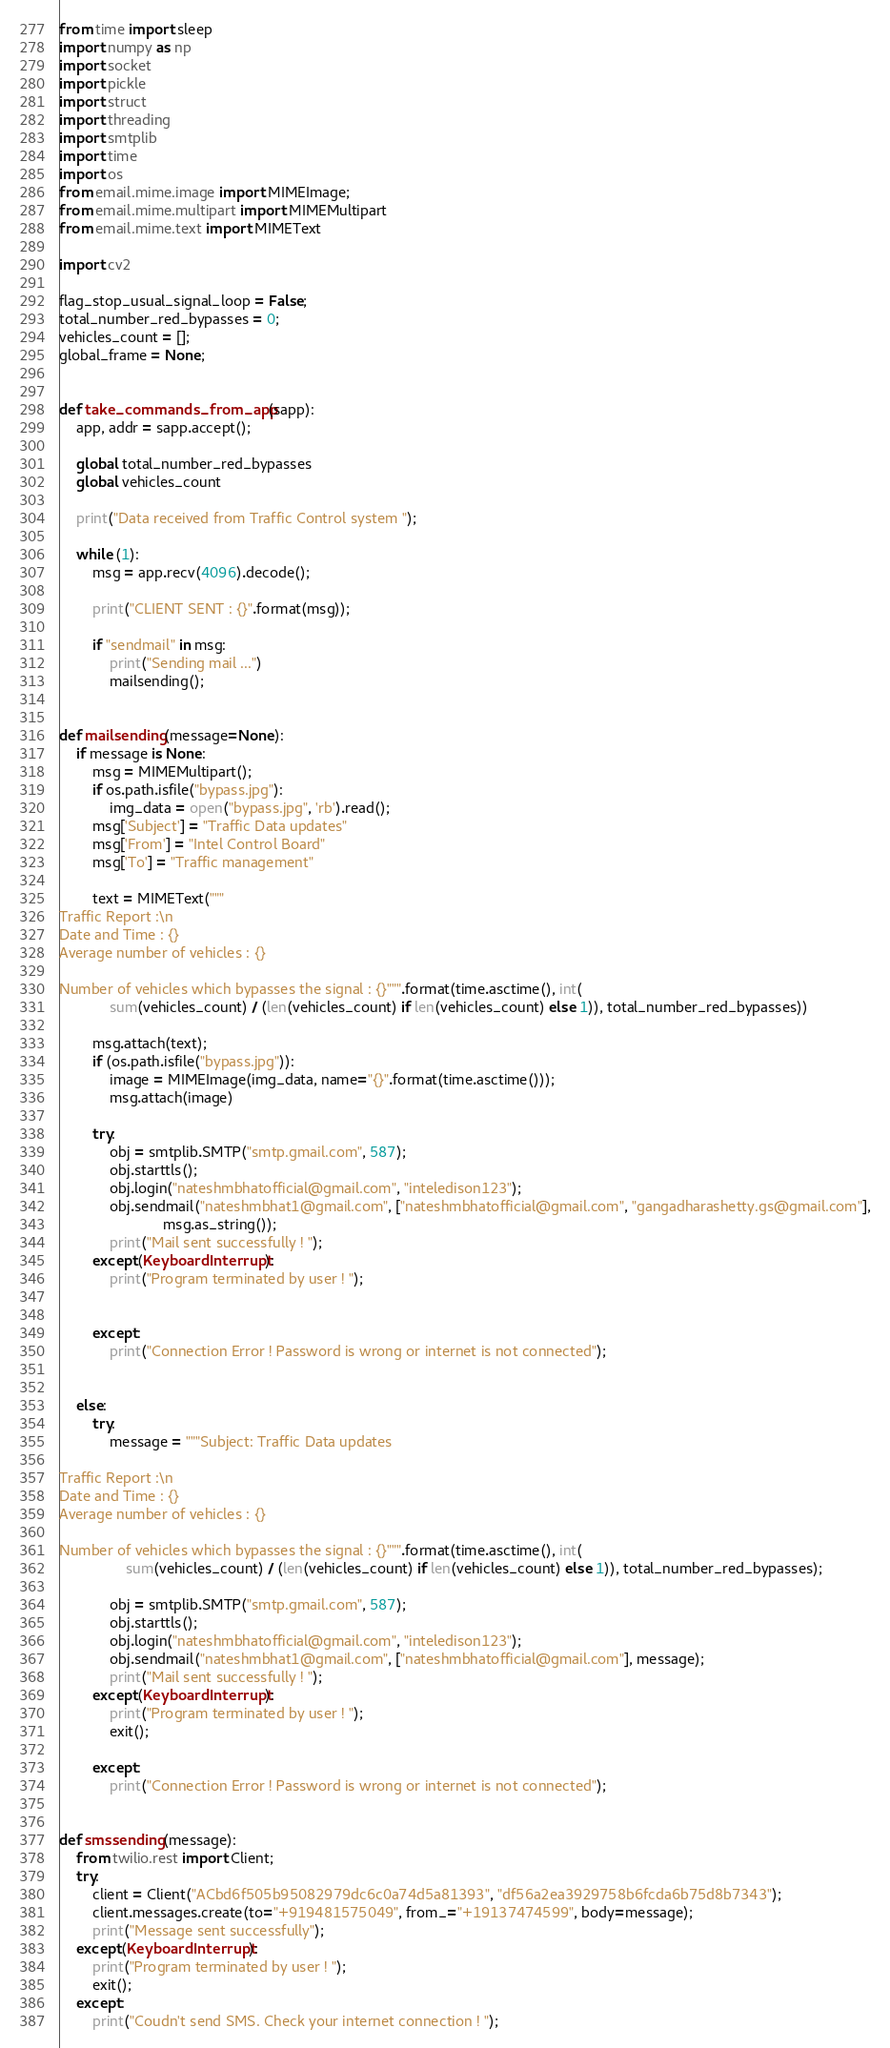<code> <loc_0><loc_0><loc_500><loc_500><_Python_>from time import sleep
import numpy as np
import socket
import pickle
import struct
import threading
import smtplib
import time
import os
from email.mime.image import MIMEImage;
from email.mime.multipart import MIMEMultipart
from email.mime.text import MIMEText

import cv2

flag_stop_usual_signal_loop = False;
total_number_red_bypasses = 0;
vehicles_count = [];
global_frame = None;


def take_commands_from_app(sapp):
    app, addr = sapp.accept();

    global total_number_red_bypasses
    global vehicles_count

    print("Data received from Traffic Control system ");

    while (1):
        msg = app.recv(4096).decode();

        print("CLIENT SENT : {}".format(msg));

        if "sendmail" in msg:
            print("Sending mail ...")
            mailsending();


def mailsending(message=None):
    if message is None:
        msg = MIMEMultipart();
        if os.path.isfile("bypass.jpg"):
            img_data = open("bypass.jpg", 'rb').read();
        msg['Subject'] = "Traffic Data updates"
        msg['From'] = "Intel Control Board"
        msg['To'] = "Traffic management"

        text = MIMEText("""
Traffic Report :\n
Date and Time : {}
Average number of vehicles : {}

Number of vehicles which bypasses the signal : {}""".format(time.asctime(), int(
            sum(vehicles_count) / (len(vehicles_count) if len(vehicles_count) else 1)), total_number_red_bypasses))

        msg.attach(text);
        if (os.path.isfile("bypass.jpg")):
            image = MIMEImage(img_data, name="{}".format(time.asctime()));
            msg.attach(image)

        try:
            obj = smtplib.SMTP("smtp.gmail.com", 587);
            obj.starttls();
            obj.login("nateshmbhatofficial@gmail.com", "inteledison123");
            obj.sendmail("nateshmbhat1@gmail.com", ["nateshmbhatofficial@gmail.com", "gangadharashetty.gs@gmail.com"],
                         msg.as_string());
            print("Mail sent successfully ! ");
        except(KeyboardInterrupt):
            print("Program terminated by user ! ");


        except:
            print("Connection Error ! Password is wrong or internet is not connected");


    else:
        try:
            message = """Subject: Traffic Data updates

Traffic Report :\n
Date and Time : {}
Average number of vehicles : {}

Number of vehicles which bypasses the signal : {}""".format(time.asctime(), int(
                sum(vehicles_count) / (len(vehicles_count) if len(vehicles_count) else 1)), total_number_red_bypasses);

            obj = smtplib.SMTP("smtp.gmail.com", 587);
            obj.starttls();
            obj.login("nateshmbhatofficial@gmail.com", "inteledison123");
            obj.sendmail("nateshmbhat1@gmail.com", ["nateshmbhatofficial@gmail.com"], message);
            print("Mail sent successfully ! ");
        except(KeyboardInterrupt):
            print("Program terminated by user ! ");
            exit();

        except:
            print("Connection Error ! Password is wrong or internet is not connected");


def smssending(message):
    from twilio.rest import Client;
    try:
        client = Client("ACbd6f505b95082979dc6c0a74d5a81393", "df56a2ea3929758b6fcda6b75d8b7343");
        client.messages.create(to="+919481575049", from_="+19137474599", body=message);
        print("Message sent successfully");
    except(KeyboardInterrupt):
        print("Program terminated by user ! ");
        exit();
    except:
        print("Coudn't send SMS. Check your internet connection ! ");

</code> 